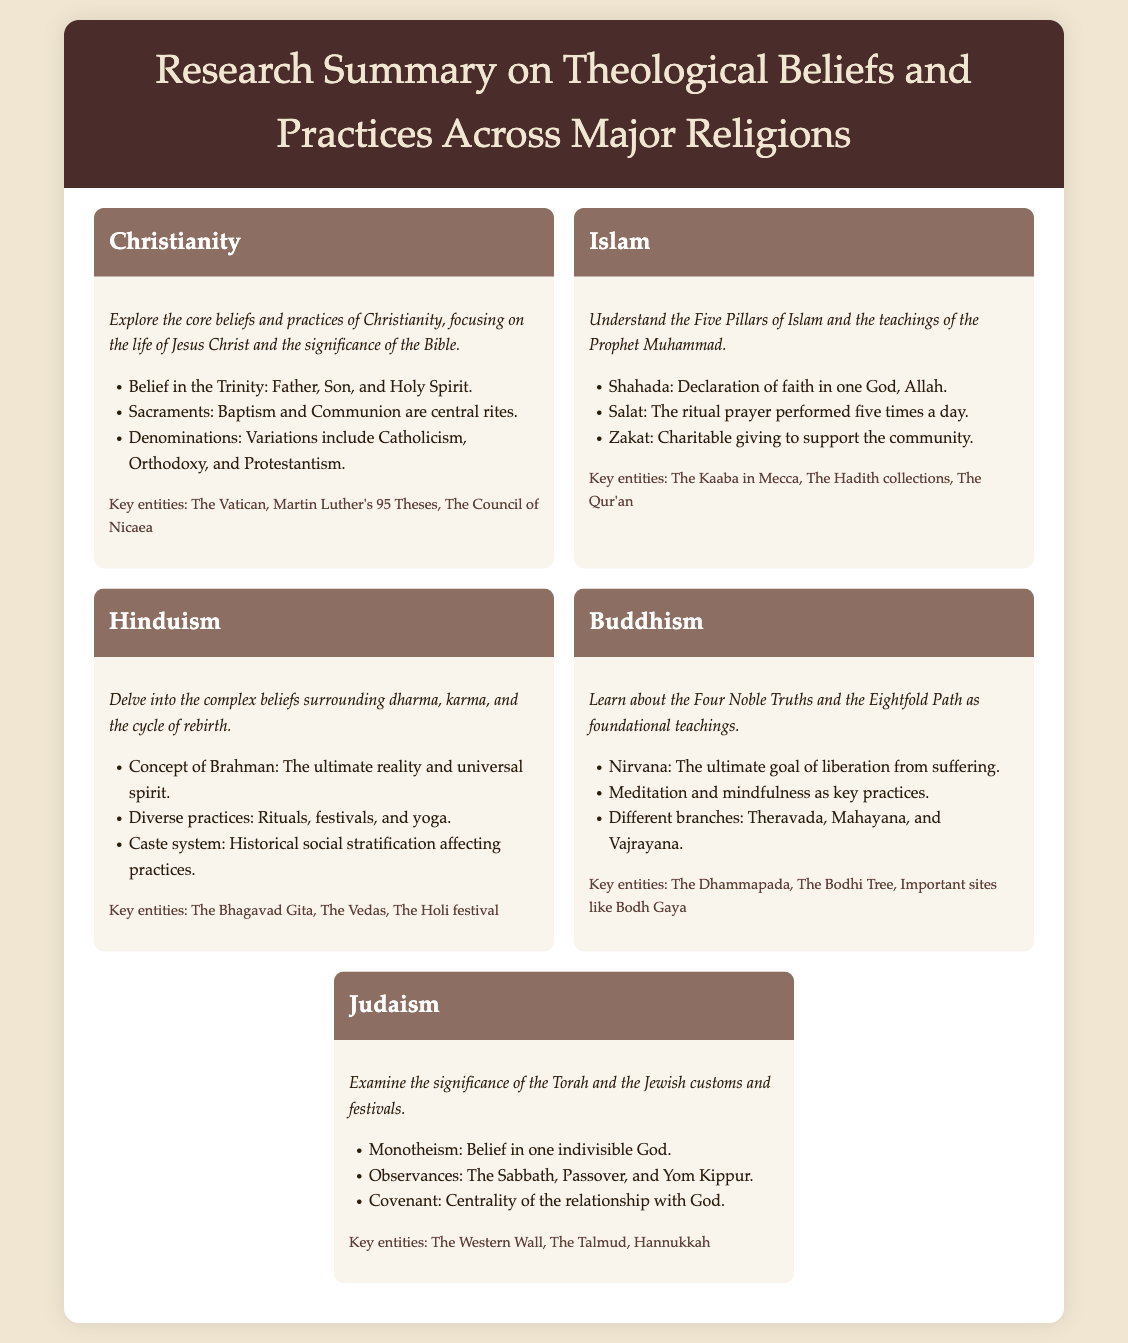What are the core beliefs of Christianity? The menu item under Christianity outlines key beliefs including the belief in the Trinity, Sacraments, and Denominations.
Answer: Belief in the Trinity: Father, Son, and Holy Spirit What is the first pillar of Islam? The menu item on Islam lists the Five Pillars, with Shahada being the first one.
Answer: Shahada: Declaration of faith in one God, Allah What is the ultimate goal in Buddhism? The Buddhism section mentions that Nirvana is the ultimate goal of liberation from suffering.
Answer: Nirvana Which text is central to Judaism? The Judaism section highlights that the Torah is significant to Jewish beliefs and customs.
Answer: The Torah What do Hindus believe about Brahman? The menu item for Hinduism includes the concept of Brahman, described as the ultimate reality.
Answer: The ultimate reality and universal spirit Name a key entity in Buddhism. The Buddhism section lists important entities including the Dhammapada and important sites.
Answer: The Dhammapada What is a significant observance in Judaism? The Judaism section enumerates several observances, including the Sabbath and Passover.
Answer: The Sabbath How many branches does Buddhism have? The Buddhism content mentions that there are various branches, specifically listed as three.
Answer: Three 